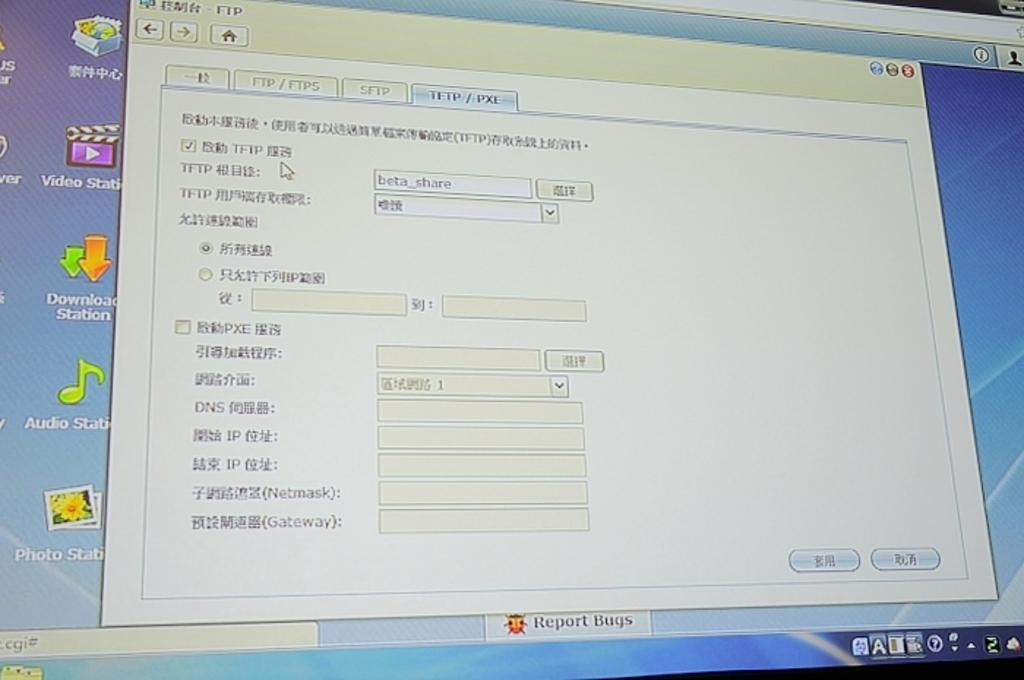<image>
Relay a brief, clear account of the picture shown. a window open on a computer monitor that has words Report Bugs on it 